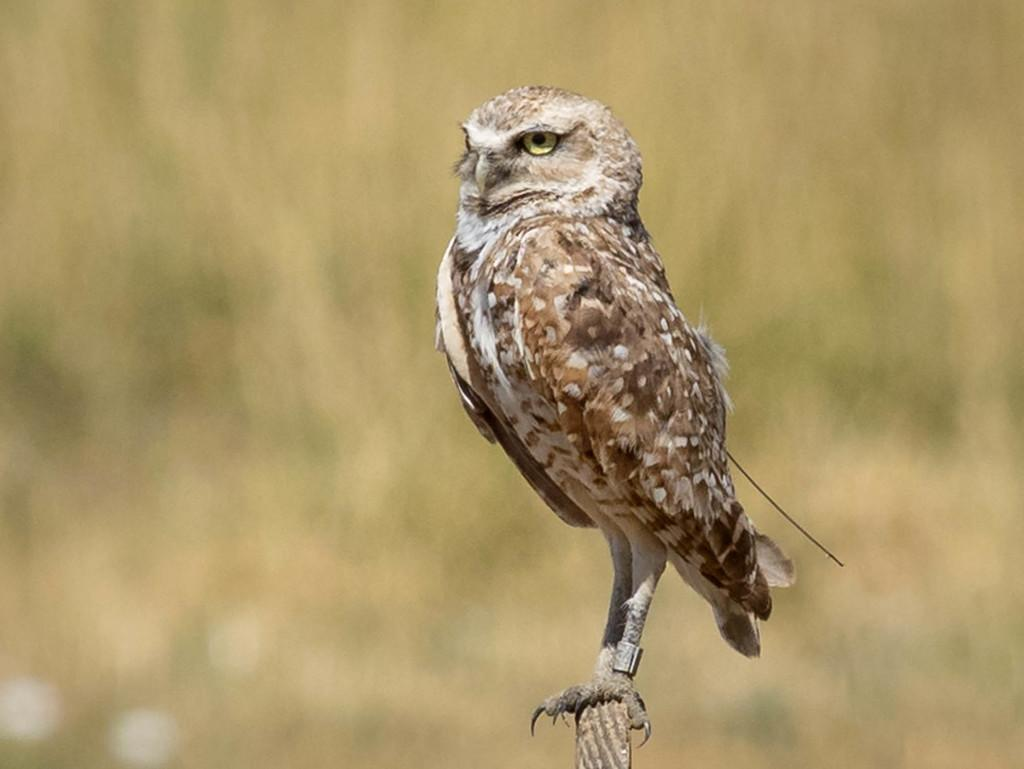What can be observed about the background of the image? The background portion of the picture is blurred. What is the main subject of the image? There is a bird in the image. Where is the bird located? The bird is on a wooden pole. What type of punishment is the bird receiving in the image? There is no indication of punishment in the image; the bird is simply perched on a wooden pole. How many beads can be seen hanging from the bird's neck in the image? There are no beads visible in the image; the bird is not wearing any accessories. 